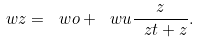<formula> <loc_0><loc_0><loc_500><loc_500>\ w z = \ w o + \ w u \frac { z } { \ z t + z } .</formula> 